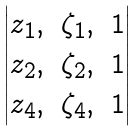<formula> <loc_0><loc_0><loc_500><loc_500>\begin{vmatrix} z _ { 1 } , & \zeta _ { 1 } , & 1 \\ z _ { 2 } , & \zeta _ { 2 } , & 1 \\ z _ { 4 } , & \zeta _ { 4 } , & 1 \\ \end{vmatrix}</formula> 